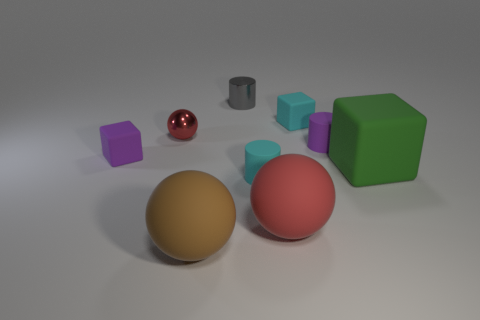There is a purple thing that is the same shape as the big green matte object; what is its material?
Make the answer very short. Rubber. Does the small cyan matte object that is in front of the green rubber thing have the same shape as the purple thing right of the big red matte ball?
Provide a short and direct response. Yes. Is the number of small gray cylinders less than the number of small purple objects?
Provide a short and direct response. Yes. What number of balls are either big blue metal objects or large red things?
Your answer should be compact. 1. What number of big spheres have the same color as the small sphere?
Make the answer very short. 1. There is a cylinder that is both on the left side of the cyan matte block and in front of the tiny gray shiny cylinder; how big is it?
Make the answer very short. Small. Is the number of small purple rubber blocks on the right side of the red matte sphere less than the number of tiny purple cubes?
Give a very brief answer. Yes. Is the material of the small cyan cube the same as the gray cylinder?
Your response must be concise. No. What number of things are either large purple matte things or large red rubber balls?
Offer a terse response. 1. What number of tiny purple things are made of the same material as the large green thing?
Make the answer very short. 2. 